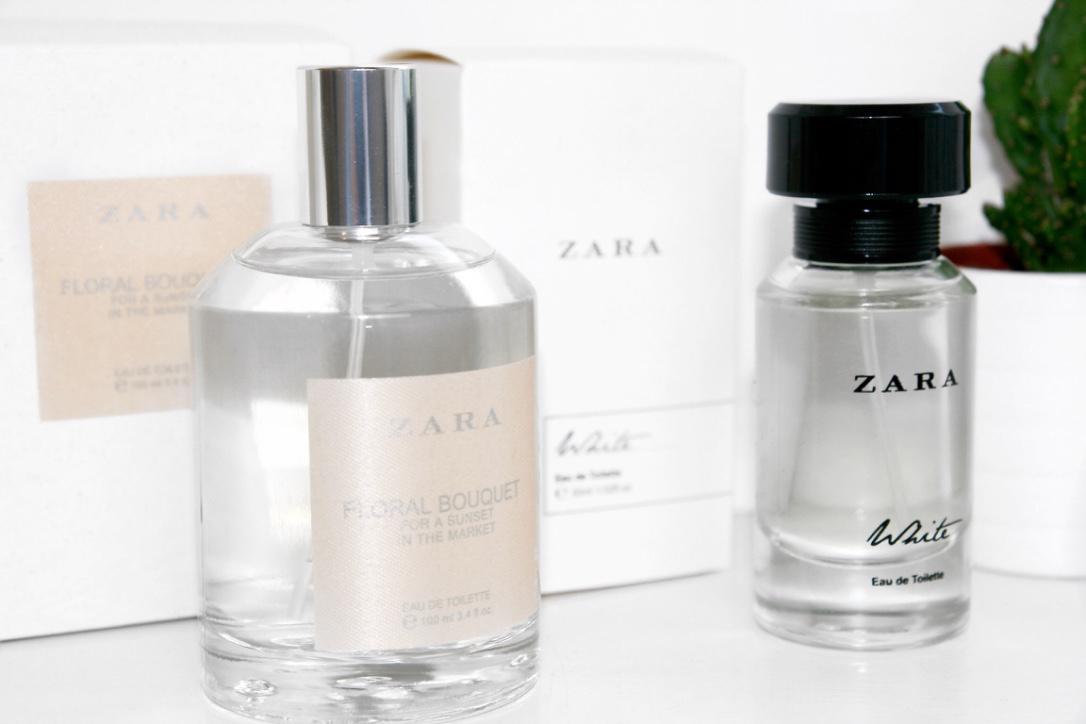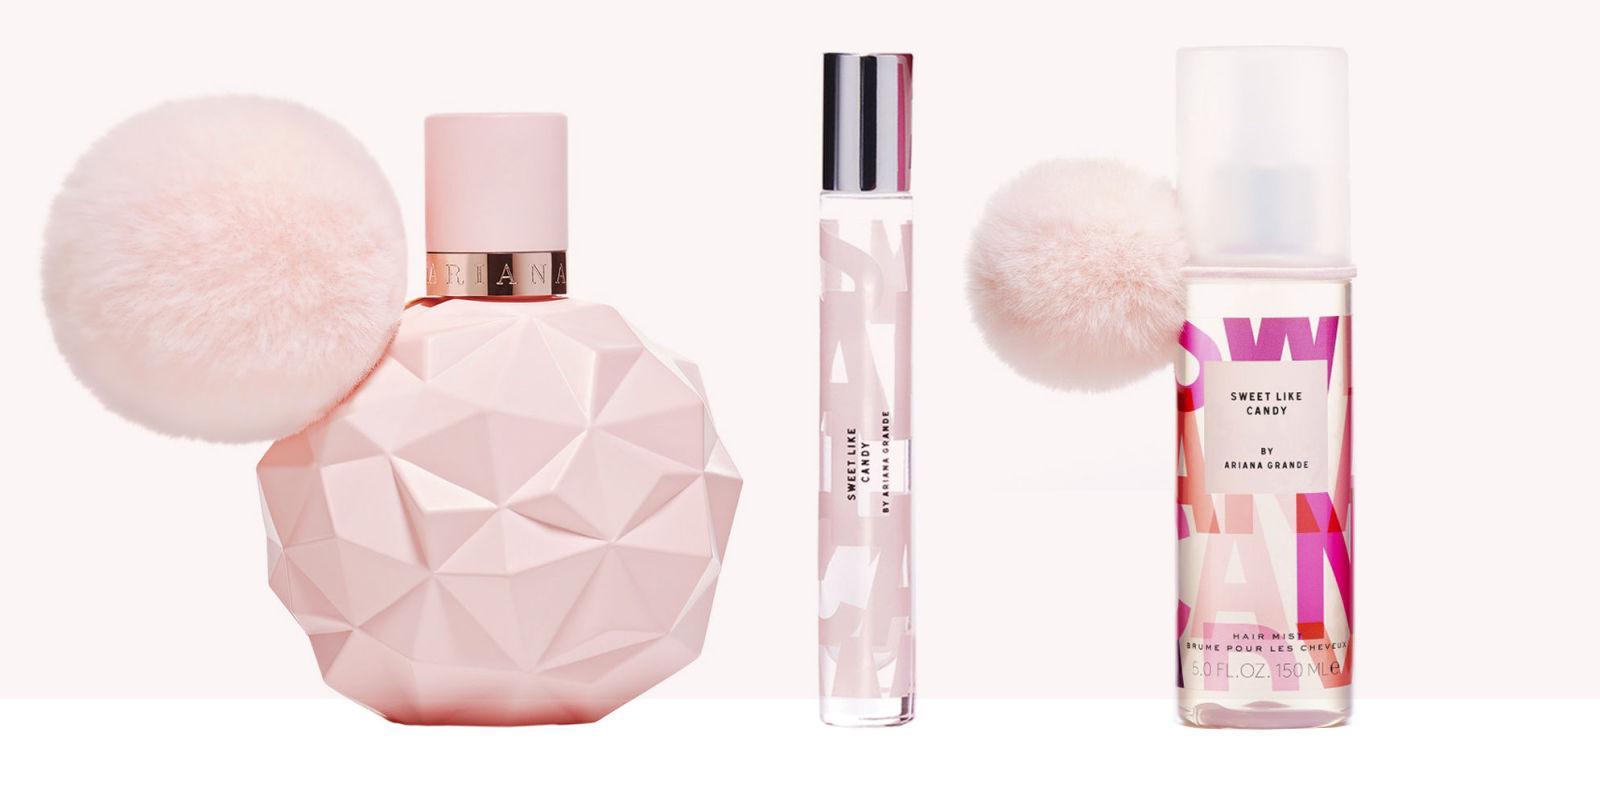The first image is the image on the left, the second image is the image on the right. For the images displayed, is the sentence "There are at least five bottles of perfume with one square bottle that has a red top with a gold stripe." factually correct? Answer yes or no. No. 